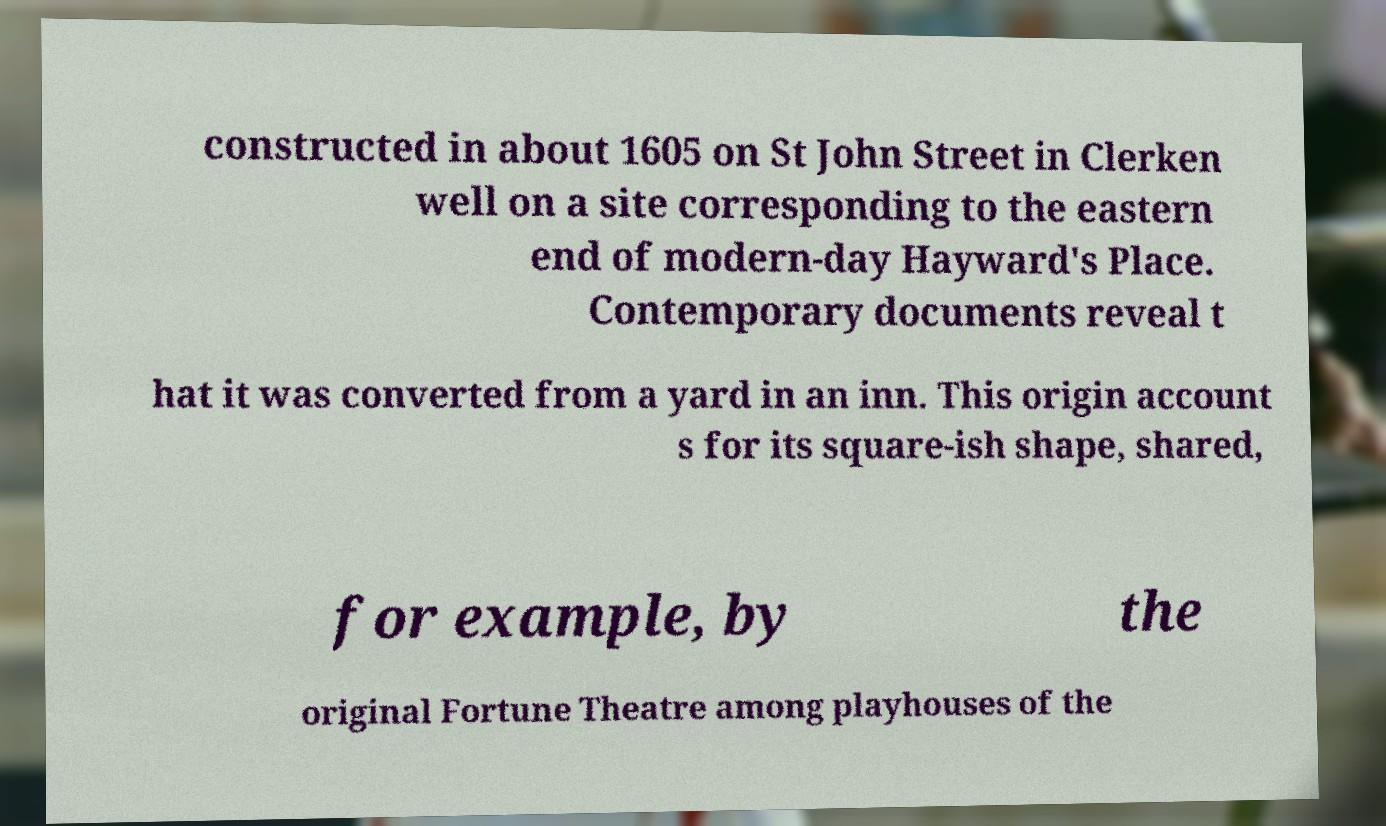What messages or text are displayed in this image? I need them in a readable, typed format. constructed in about 1605 on St John Street in Clerken well on a site corresponding to the eastern end of modern-day Hayward's Place. Contemporary documents reveal t hat it was converted from a yard in an inn. This origin account s for its square-ish shape, shared, for example, by the original Fortune Theatre among playhouses of the 